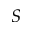<formula> <loc_0><loc_0><loc_500><loc_500>S</formula> 